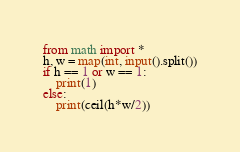<code> <loc_0><loc_0><loc_500><loc_500><_Python_>from math import *
h, w = map(int, input().split())
if h == 1 or w == 1:
    print(1)
else:
    print(ceil(h*w/2))</code> 